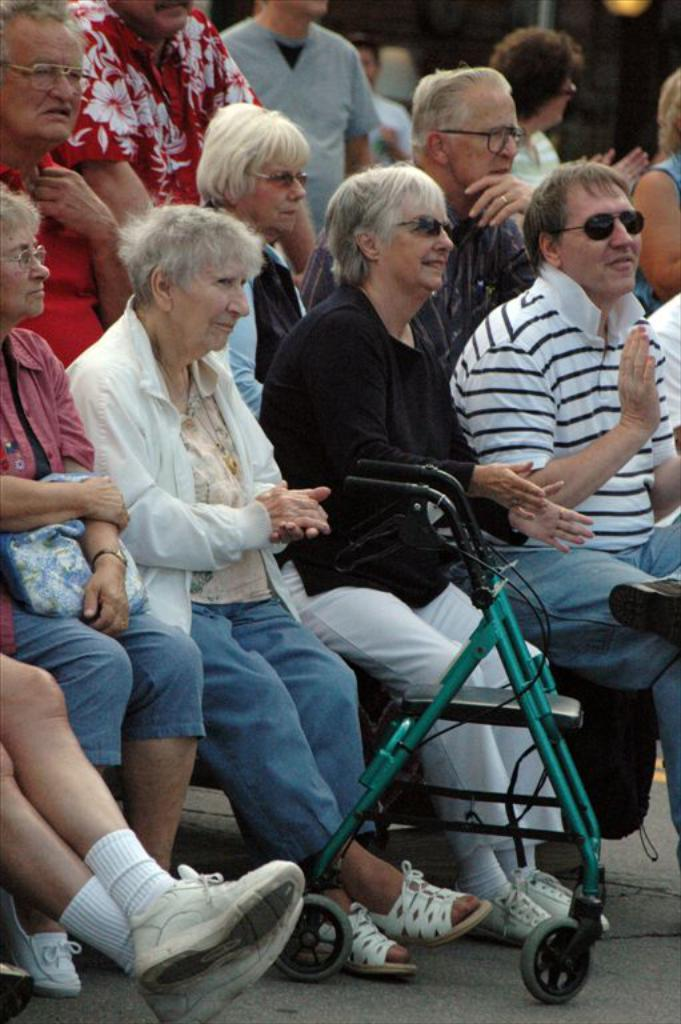What are the people in the image doing? There are people sitting and standing in the image. Can you describe the vehicle in the image? There is a vehicle on the road in the image. What type of flower can be seen growing in the image? There is no flower present in the image. What scientific discovery is being made in the image? There is no scientific discovery being made in the image; it simply shows people sitting and standing with a vehicle on the road. 